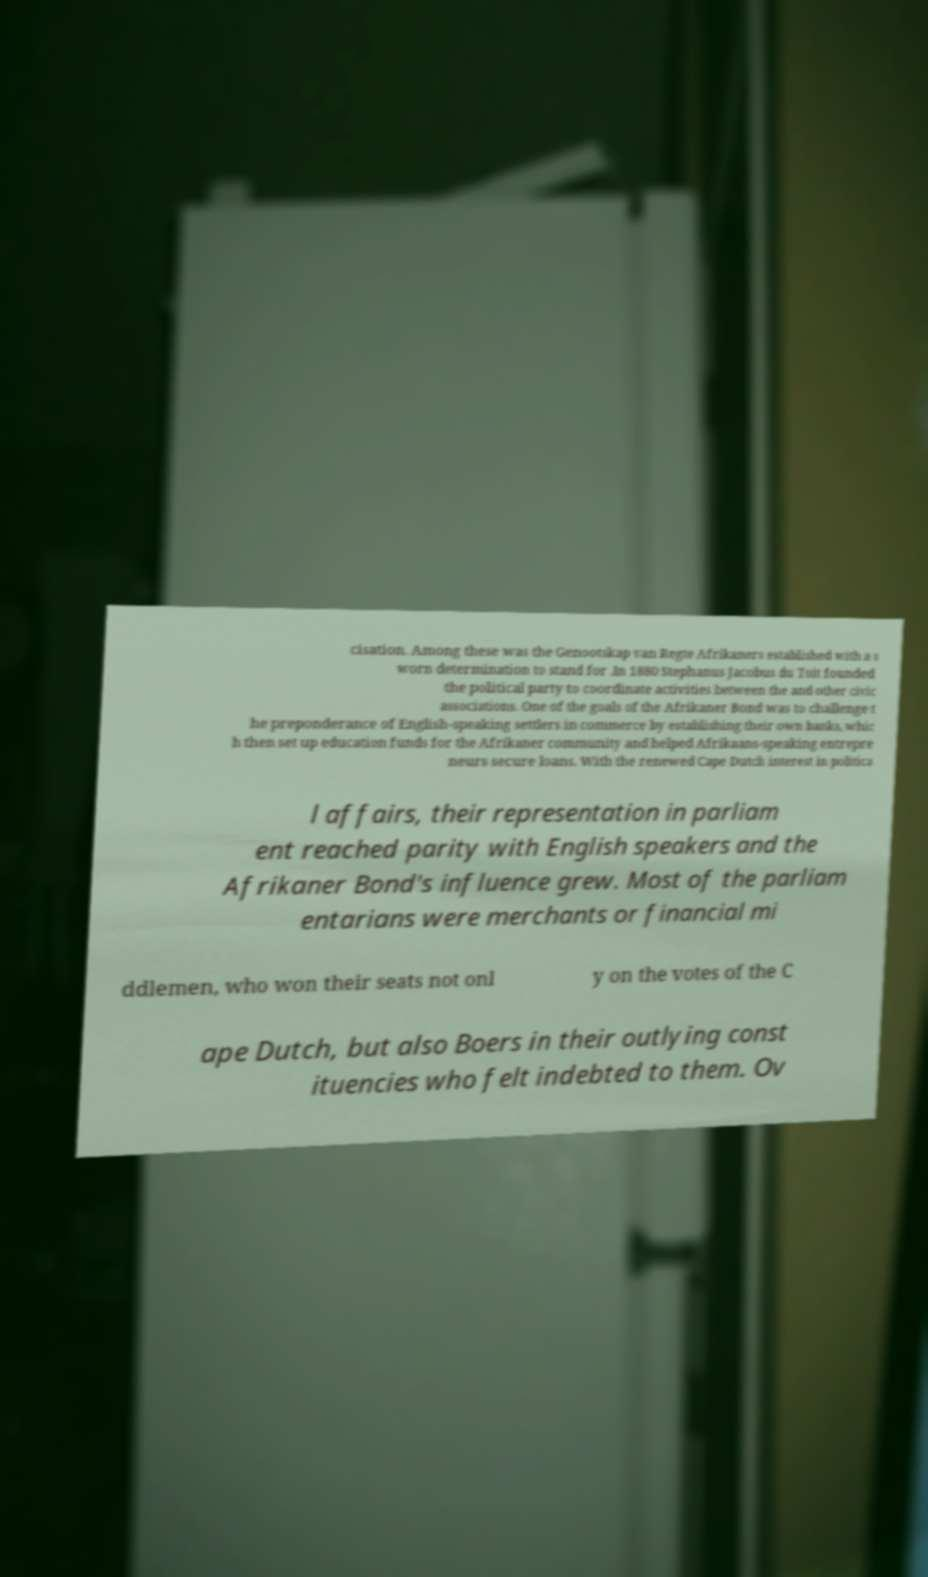What messages or text are displayed in this image? I need them in a readable, typed format. cisation. Among these was the Genootskap van Regte Afrikaners established with a s worn determination to stand for .In 1880 Stephanus Jacobus du Toit founded the political party to coordinate activities between the and other civic associations. One of the goals of the Afrikaner Bond was to challenge t he preponderance of English-speaking settlers in commerce by establishing their own banks, whic h then set up education funds for the Afrikaner community and helped Afrikaans-speaking entrepre neurs secure loans. With the renewed Cape Dutch interest in politica l affairs, their representation in parliam ent reached parity with English speakers and the Afrikaner Bond's influence grew. Most of the parliam entarians were merchants or financial mi ddlemen, who won their seats not onl y on the votes of the C ape Dutch, but also Boers in their outlying const ituencies who felt indebted to them. Ov 